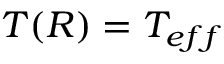Convert formula to latex. <formula><loc_0><loc_0><loc_500><loc_500>T ( R ) = T _ { e f f }</formula> 